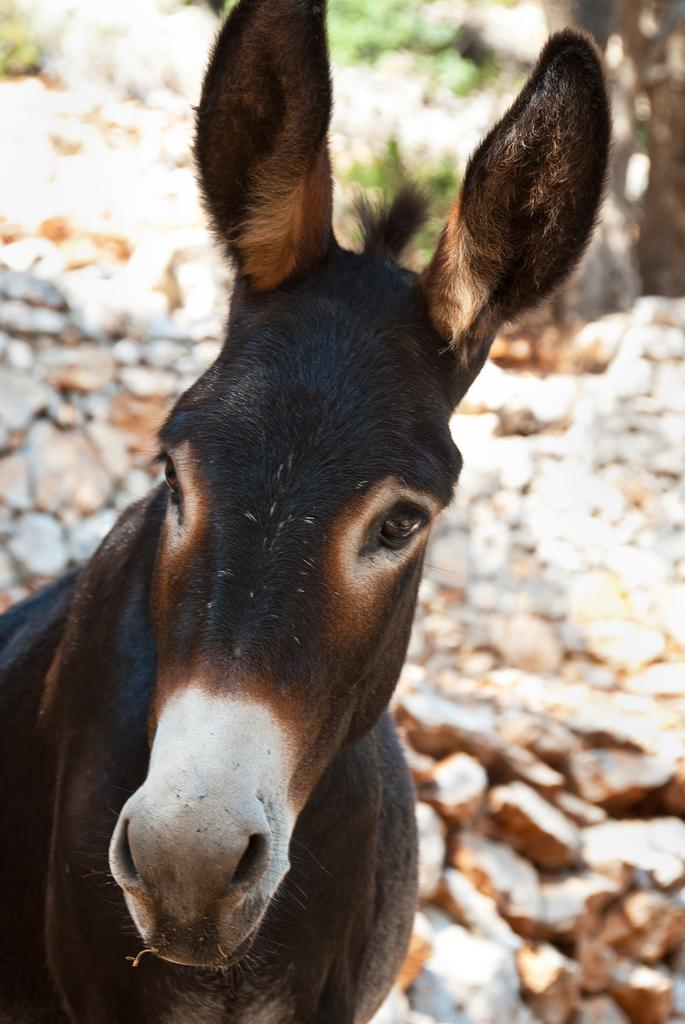What type of living creature is in the image? There is an animal in the image. What other objects or features can be seen in the image? There are rocks and plants in the image. How would you describe the background of the image? The background of the image is blurred. What type of men can be seen leading the unit in the image? There are no men or units present in the image; it features an animal, rocks, and plants. 